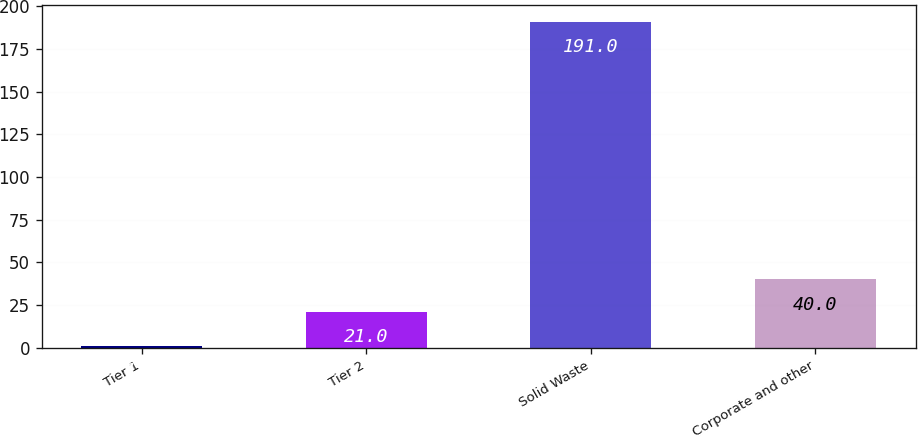<chart> <loc_0><loc_0><loc_500><loc_500><bar_chart><fcel>Tier 1<fcel>Tier 2<fcel>Solid Waste<fcel>Corporate and other<nl><fcel>1<fcel>21<fcel>191<fcel>40<nl></chart> 